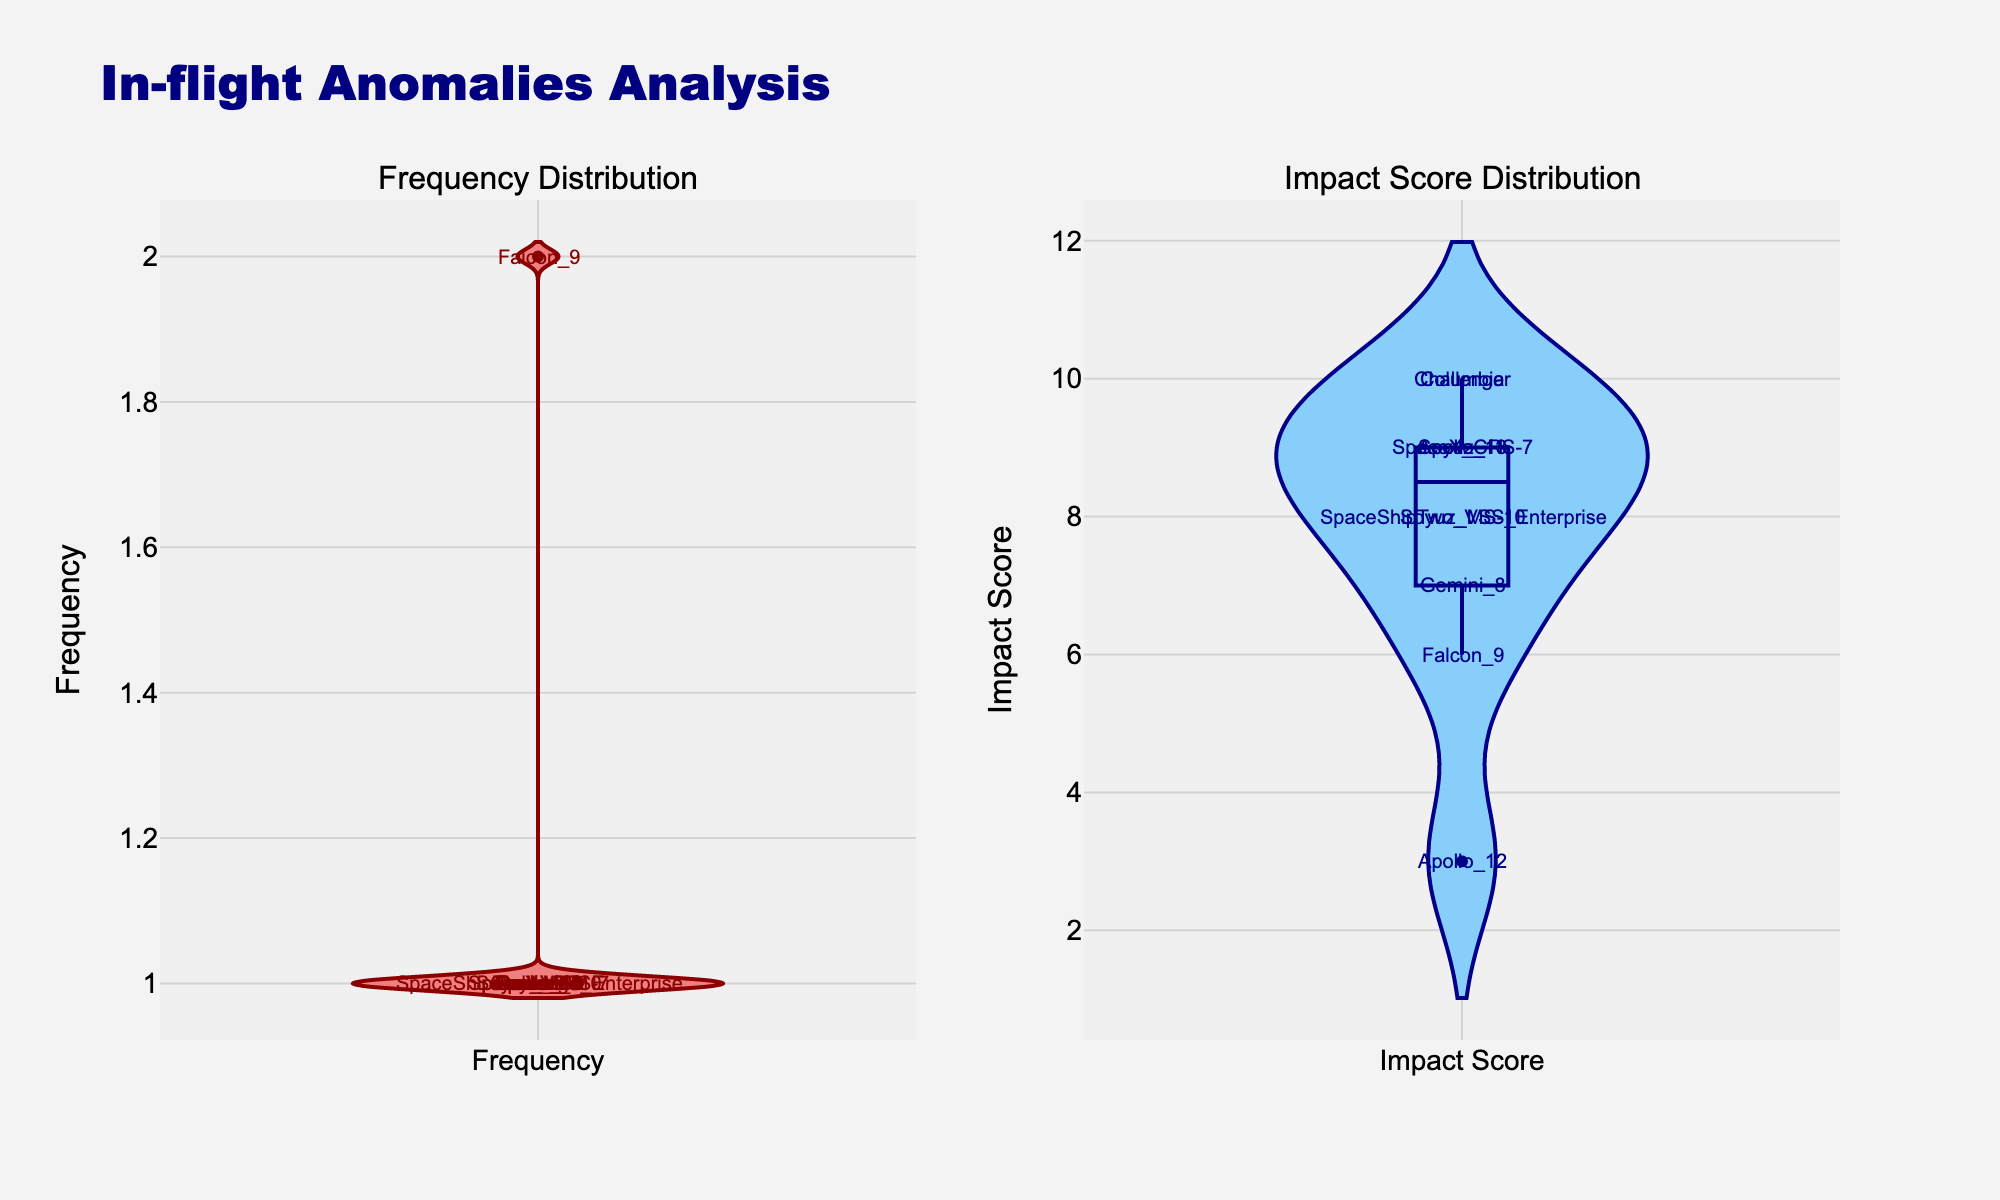What is the title of the figure? The title is usually found at the top of the figure. In this case, it is specified to be "In-flight Anomalies Analysis".
Answer: In-flight Anomalies Analysis How many subplots are in the figure? The figure is divided into two parts, one for each subplot, labeled "Frequency Distribution" and "Impact Score Distribution".
Answer: 2 What color is used for the violin plot representing 'Frequency'? The violin plot for 'Frequency' is described to use 'darkred' for the line and 'lightcoral' for the fill.
Answer: lightcoral Which anomaly type has the highest impact score? The highest impact score can be seen in the subplot titled "Impact Score Distribution". The tallest point at the score of 10 is for Challenger and Columbia.
Answer: Structural Failure and Thermal Protection Failure What is the range of values for the Frequency subplot? By analyzing the y-axis of the Frequency violin plot, it ranges from 1 to 2.
Answer: 1 to 2 What is the median Impact Score? The figure shows a distribution of Impact Scores. The median can be visually estimated as the value that divides the plot into two equal halves, likely near the center of the plot for impact.
Answer: 9 How does the distribution of Frequency compare to the distribution of Impact Score? The Frequency distribution has less variation (only values of 1 and 2) compared to the wider range of Impact Scores, which range from 3 to 10, indicating more variability in impact.
Answer: More varied distribution of Impact Scores Which mission had an anomaly classified as an Impact Score of 3? The annotated labels on the figure can help identify the outlier score. Apollo_12 is marked at an Impact Score of 3.
Answer: Apollo_12 How many missions experienced an anomaly with an Impact Score of 10? By reviewing the "Impact Score Distribution" subplot, we see two distinct annotations on the y-axis at score 10, corresponding to Challenger and Columbia missions.
Answer: 2 Compare the lowest observed Impact Score with the most frequent Frequency value. The lowest Impact Score observed is 3, while the most frequent Frequency value observed is 1. The range of frequencies is smaller and less diverse compared to impact scores.
Answer: 3 vs 1 